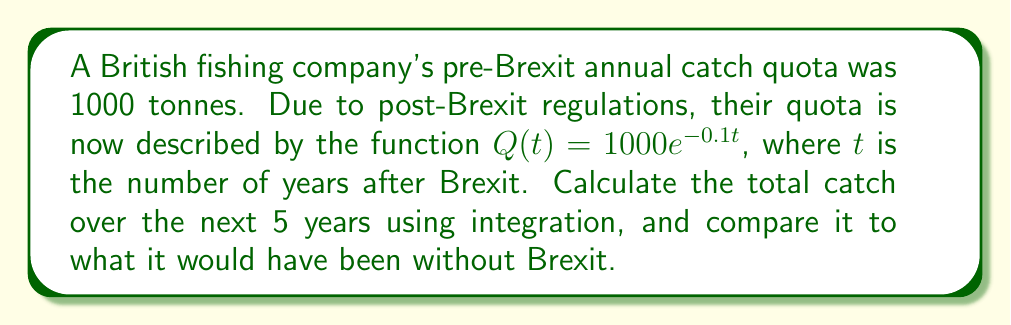Could you help me with this problem? 1) To find the total catch over 5 years, we need to integrate $Q(t)$ from 0 to 5:

   $$\int_0^5 Q(t) dt = \int_0^5 1000e^{-0.1t} dt$$

2) Integrate using the rule for exponentials:

   $$= -10000e^{-0.1t} \bigg|_0^5$$

3) Evaluate the integral:

   $$= -10000(e^{-0.5} - e^0) = -10000(0.6065 - 1) = 3935$$

4) The total catch over 5 years post-Brexit is 3935 tonnes.

5) Without Brexit, the catch would have remained constant at 1000 tonnes per year:

   $$5 \times 1000 = 5000\text{ tonnes}$$

6) The difference:

   $$5000 - 3935 = 1065\text{ tonnes}$$

This represents a loss of 1065 tonnes over 5 years due to Brexit regulations.
Answer: 3935 tonnes (1065 tonnes less than pre-Brexit) 